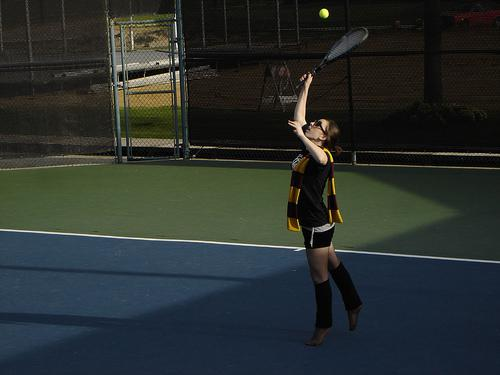Question: who is wearing a scarf?
Choices:
A. A boy.
B. A man.
C. A woman.
D. A girl.
Answer with the letter. Answer: D Question: who is playing tennis?
Choices:
A. A boy.
B. A girl.
C. A man.
D. A woman.
Answer with the letter. Answer: B Question: what part of the tennis court is the girl standing on?
Choices:
A. The back.
B. The front.
C. The blue.
D. The right side.
Answer with the letter. Answer: C Question: what is the girl about to do?
Choices:
A. Hit a tennis ball.
B. Hit a baseball.
C. Shoot a basketball.
D. Throw a football.
Answer with the letter. Answer: A 